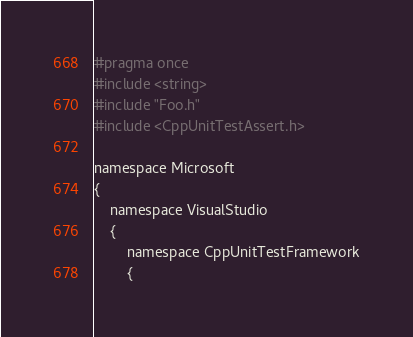Convert code to text. <code><loc_0><loc_0><loc_500><loc_500><_C_>#pragma once
#include <string>
#include "Foo.h"
#include <CppUnitTestAssert.h>

namespace Microsoft
{
    namespace VisualStudio
    {
        namespace CppUnitTestFramework
        {</code> 